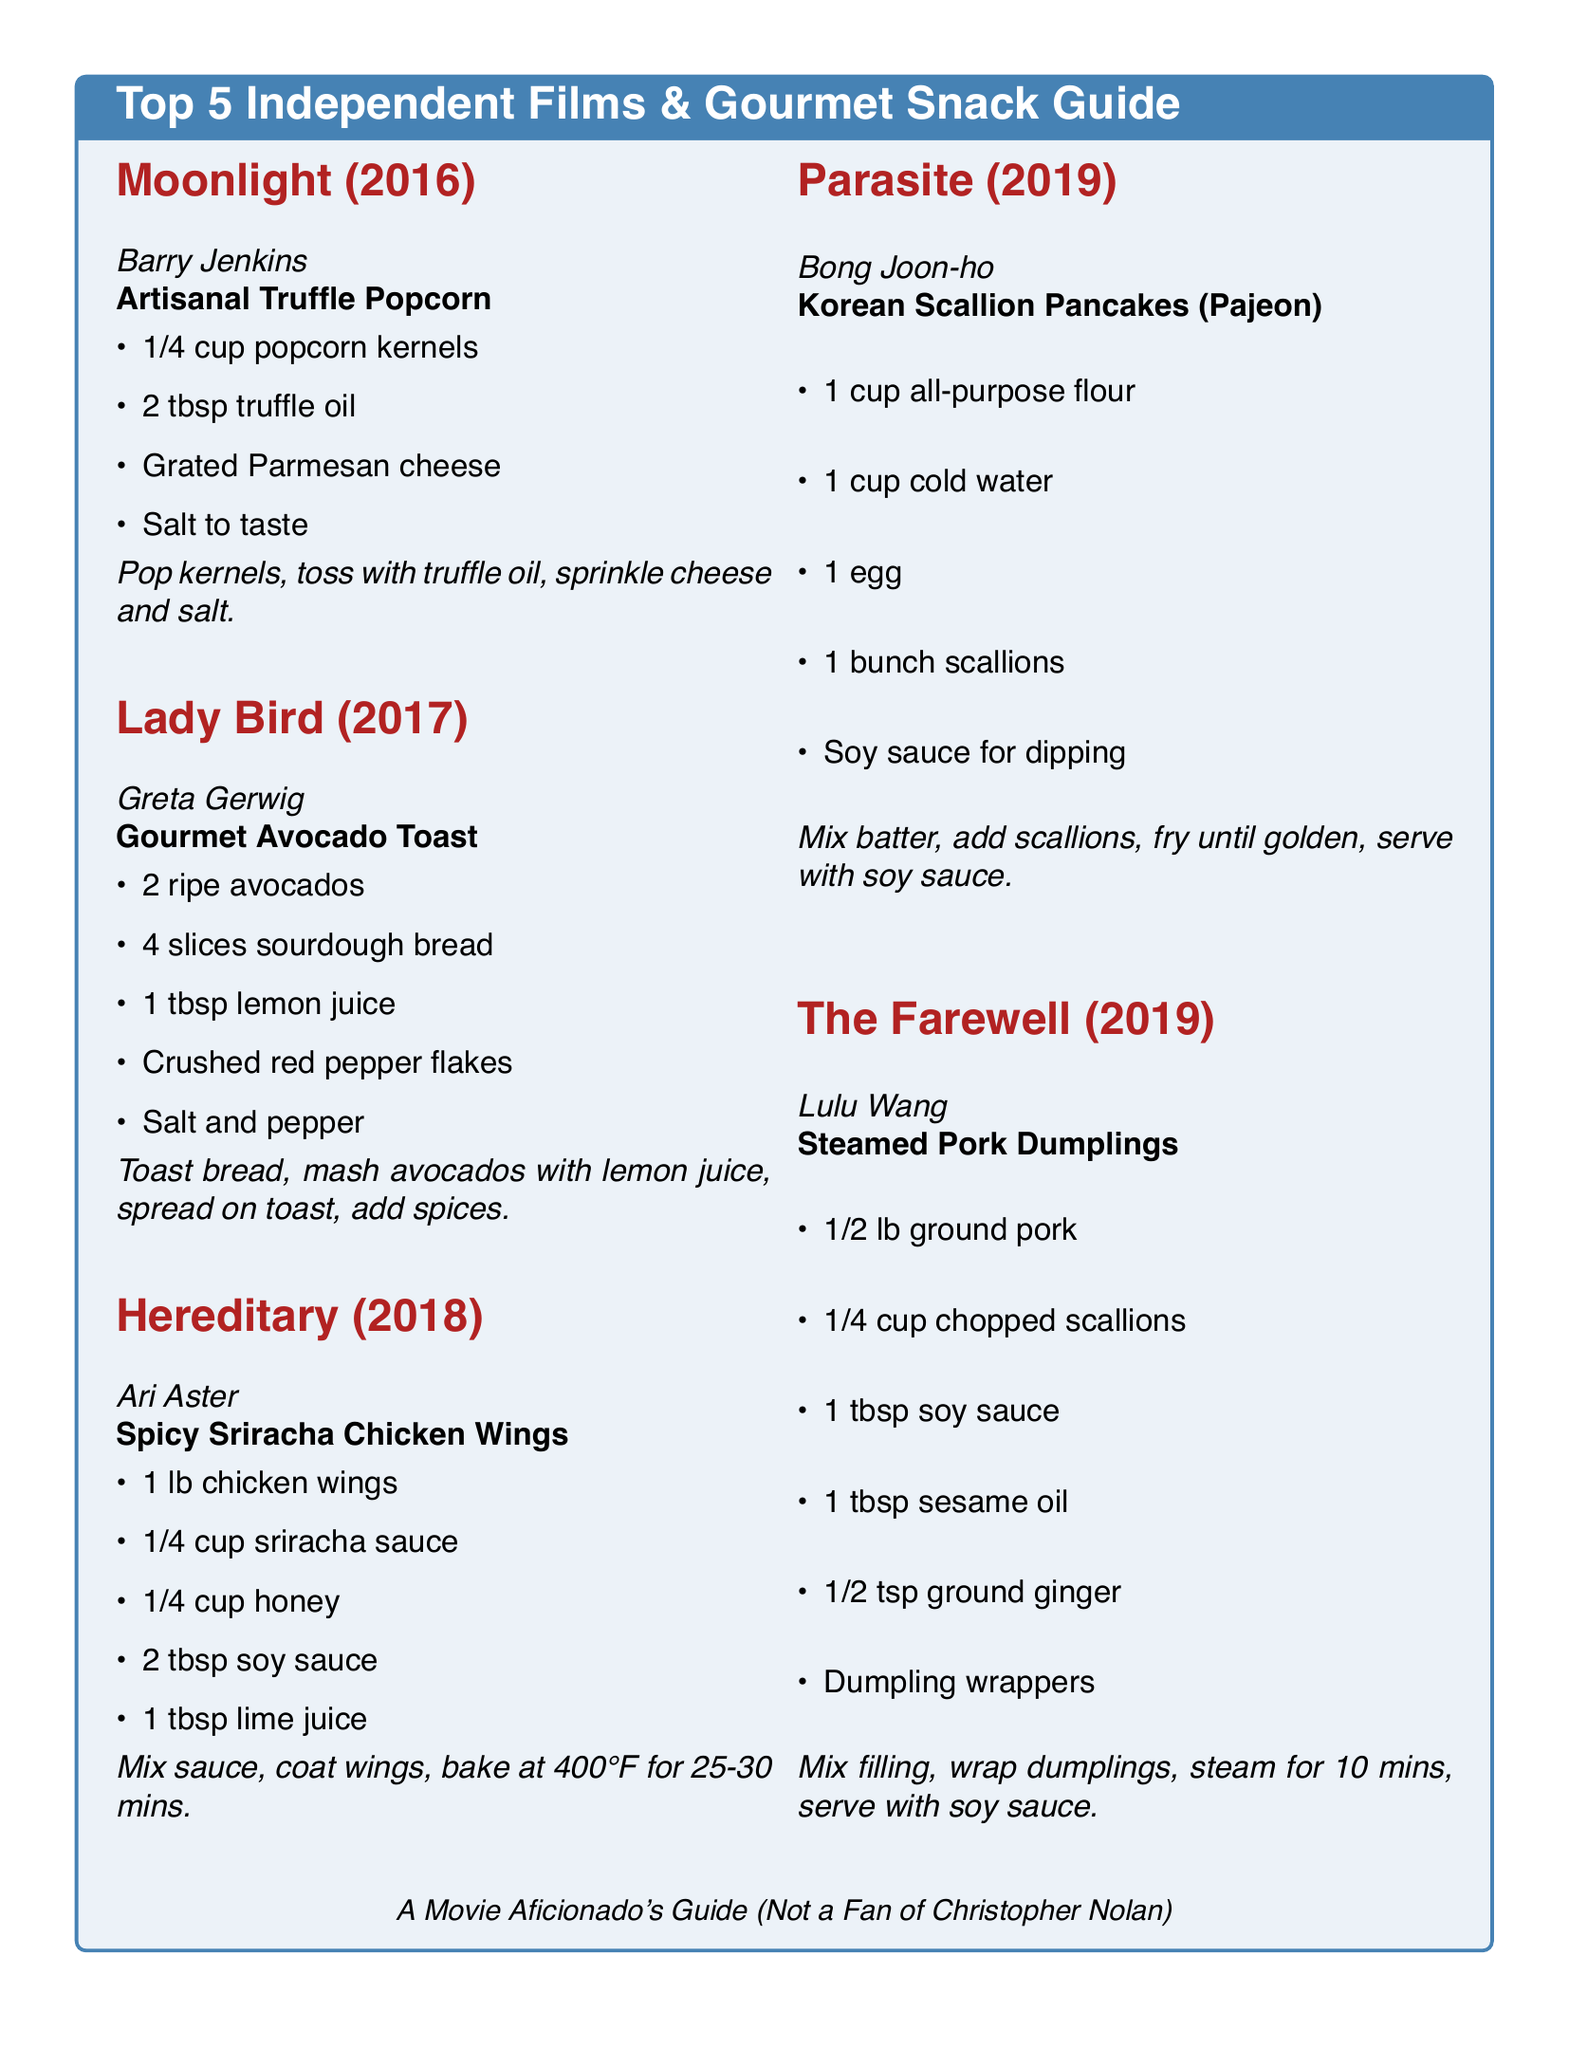What is the title of the first film mentioned? The title of the first film is highlighted in the top section of the document under the actor's name.
Answer: Moonlight (2016) What genre does the film "Hereditary" belong to? The genre can be inferred from the film's name, style, and the context of snacks paired with it.
Answer: Horror What is the main ingredient in the snack paired with "Parasite"? The snack is described with a list of ingredients, highlighting the primary one in the recipe section.
Answer: Scallions How long should you bake the chicken wings for "Hereditary"? The cooking time is specified in the instructions for preparing the wings in the document.
Answer: 25-30 mins What type of bread is used for the gourmet snack in "Lady Bird"? The type of bread is explicitly mentioned in the ingredients list for the snack accompanying the film.
Answer: Sourdough What is the measure of popcorn kernels for "Moonlight"? The document indicates the quantity of popcorn kernels in the ingredient list for the associated snack.
Answer: 1/4 cup Which film's snack involves steaming? The cooking method for the snack is cited in the instructions for one of the listed films.
Answer: The Farewell What sauce is suggested for dipping with the Korean scallion pancakes? The document specifies a condiment for the pancakes, making this essential information in the recipe.
Answer: Soy sauce What is the last film mentioned in the list? The last film is listed at the end of the section and is coupled with its respective snack.
Answer: The Farewell (2019) 